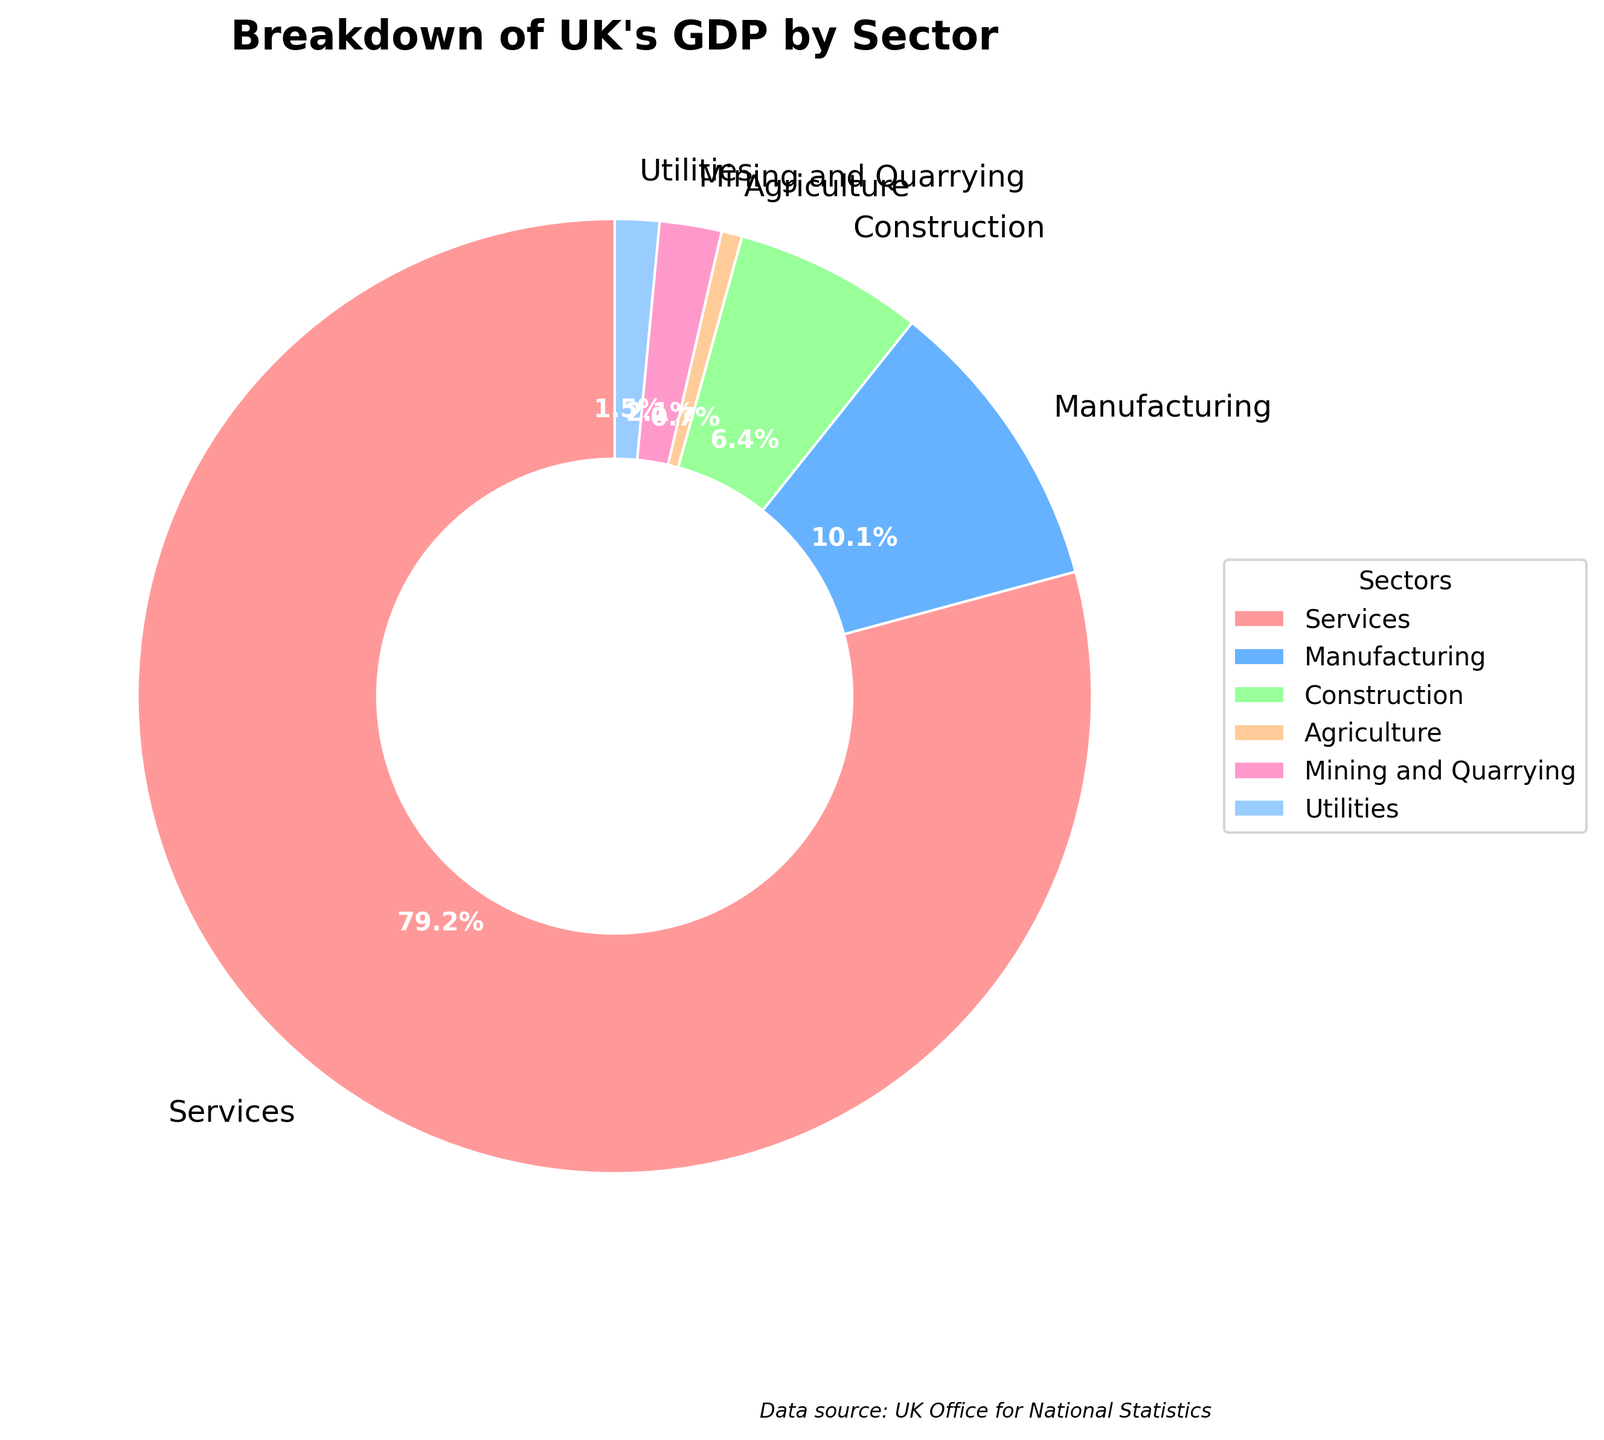What percentage of the UK's GDP does the Services sector contribute? The Services sector contributes a significant portion of the GDP. According to the pie chart, the Services sector takes up the largest segment.
Answer: 79.2% How much more does the Manufacturing sector contribute to the GDP compared to the Agriculture sector? To find this, subtract the Agriculture sector's contribution from the Manufacturing sector's contribution. That is 10.1% - 0.7%.
Answer: 9.4% Which sector is the smallest contributor to the UK's GDP? By examining the segments of the pie chart, the smallest sector is the one with the least percentage area, which is clearly indicated.
Answer: Agriculture Are Manufacturing and Construction sectors combined larger than the Services sector? Add the percentages of Manufacturing and Construction sectors first, which is 10.1% + 6.4%, and compare the sum to the Services sector's percentage. 16.5% compared to 79.2%.
Answer: No Calculate the total percentage of the UK's GDP taken by the Manufacturing, Agriculture, Mining and Quarrying, and Utilities sectors. Sum these percentages: Manufacturing (10.1%) + Agriculture (0.7%) + Mining and Quarrying (2.1%) + Utilities (1.5%), which equals 14.4%.
Answer: 14.4% Which sectors combined make up more than a quarter (25%) of the UK's GDP? Identify sectors whose percentages add up to more than 25%. Services alone is 79.2%, which is greater than 25%. No need to combine other sectors also.
Answer: Services Is the Services sector more than four times larger than the next biggest sector? The Services sector is 79.2%. The next biggest sector is Manufacturing at 10.1%. Check if 79.2% is more than 4 times 10.1%. 4 times 10.1 is 40.4, which is less than 79.2%.
Answer: Yes Which sectors contribute the least and the most to the GDP? By comparing the sizes of the pie chart segments, the sector with the largest and smallest areas can be identified. Services have the most, and Agriculture has the least.
Answer: Agriculture and Services What is the total percentage contribution of sectors other than Services? Subtract the percentage of the Services sector from 100%: 100% - 79.2% = 20.8%.
Answer: 20.8% If the Mining and Quarrying and Utilities sectors were combined, would their total percentage exceed that of Construction? Add the percentages of Mining and Quarrying (2.1%) and Utilities (1.5%) and compare to Construction (6.4%). The sum is 2.1% + 1.5% = 3.6%, which is less than 6.4%.
Answer: No 